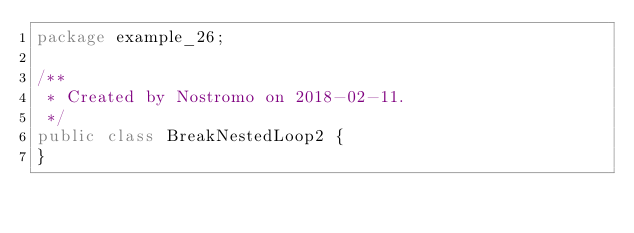<code> <loc_0><loc_0><loc_500><loc_500><_Java_>package example_26;

/**
 * Created by Nostromo on 2018-02-11.
 */
public class BreakNestedLoop2 {
}
</code> 